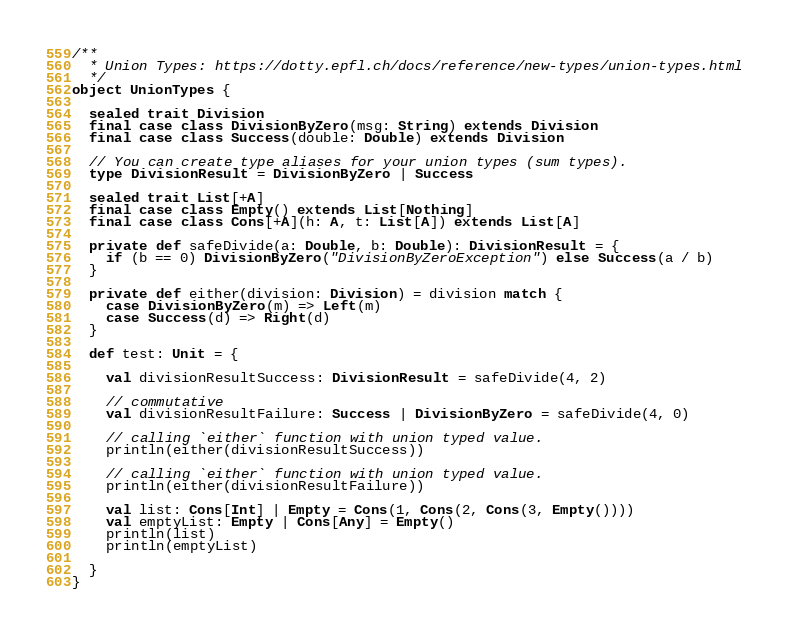<code> <loc_0><loc_0><loc_500><loc_500><_Scala_>/**
  * Union Types: https://dotty.epfl.ch/docs/reference/new-types/union-types.html
  */
object UnionTypes {

  sealed trait Division
  final case class DivisionByZero(msg: String) extends Division
  final case class Success(double: Double) extends Division

  // You can create type aliases for your union types (sum types).
  type DivisionResult = DivisionByZero | Success

  sealed trait List[+A]
  final case class Empty() extends List[Nothing]
  final case class Cons[+A](h: A, t: List[A]) extends List[A]

  private def safeDivide(a: Double, b: Double): DivisionResult = {
    if (b == 0) DivisionByZero("DivisionByZeroException") else Success(a / b)
  }

  private def either(division: Division) = division match {
    case DivisionByZero(m) => Left(m)
    case Success(d) => Right(d)
  }

  def test: Unit = {

    val divisionResultSuccess: DivisionResult = safeDivide(4, 2)

    // commutative
    val divisionResultFailure: Success | DivisionByZero = safeDivide(4, 0)

    // calling `either` function with union typed value.
    println(either(divisionResultSuccess))

    // calling `either` function with union typed value.
    println(either(divisionResultFailure))

    val list: Cons[Int] | Empty = Cons(1, Cons(2, Cons(3, Empty())))
    val emptyList: Empty | Cons[Any] = Empty()
    println(list)
    println(emptyList)

  }
}
</code> 